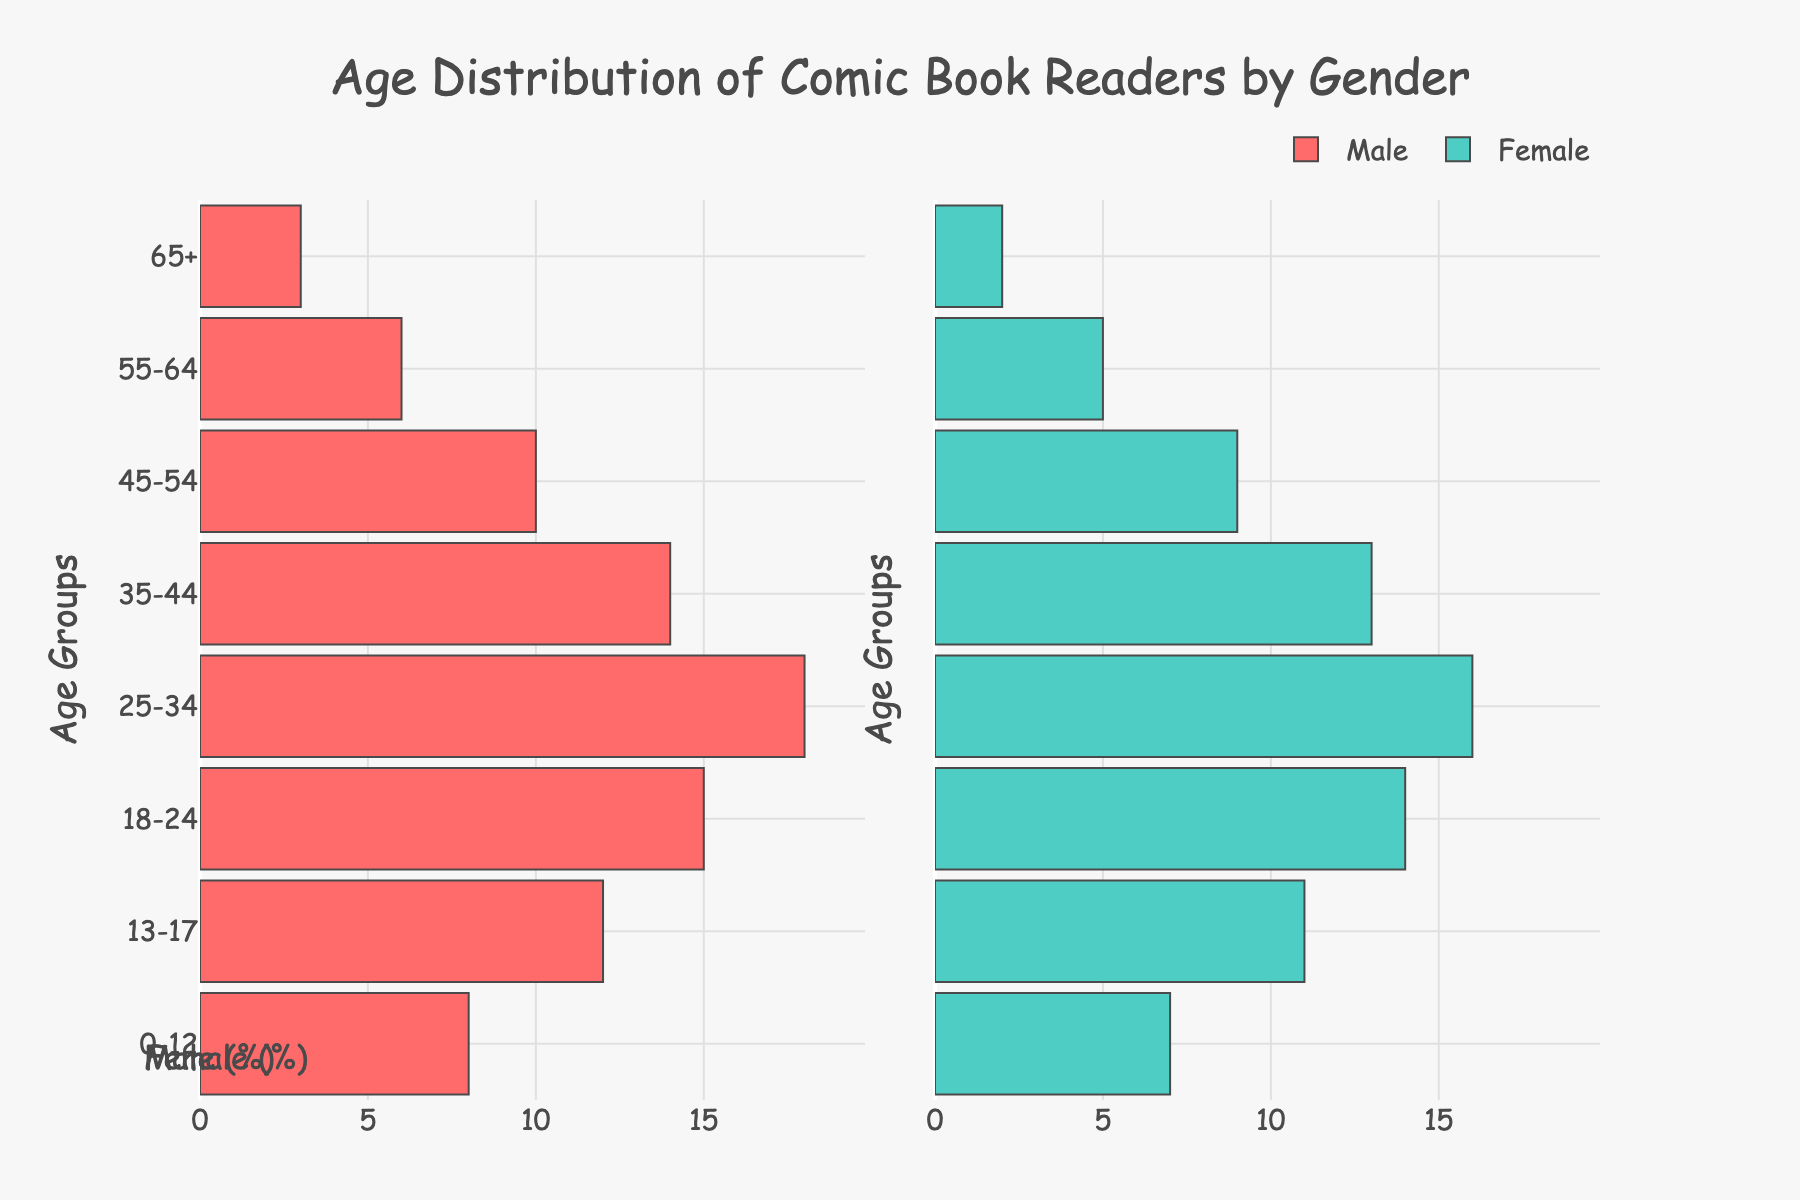What's the title of the figure? The title is located at the top of the figure and reads "Age Distribution of Comic Book Readers by Gender".
Answer: Age Distribution of Comic Book Readers by Gender What color represents male readers in the figure? The color representing male readers in the figure is red.
Answer: Red Which age group has the highest number of male comic book readers? To find the highest number, look at the length of the red bars and identify the age group with the longest bar. The "25-34" age group has the longest red bar.
Answer: 25-34 How many female comic book readers are in the "18-24" age group? Find the bar for the "18-24" age group in the female section (right side, green bar) and read its value, which is 14%.
Answer: 14 Which age group has the least number of comic book readers, regardless of gender? Compare the bars for both male and female readers across all age groups. The "65+" group has the smallest combined bar lengths for both genders.
Answer: 65+ In which age group is the gender distribution of comic book readers closest to equal? Look for age groups where the lengths of the red and green bars are most similar. The "35-44" group has bars that are relatively close in length for both genders.
Answer: 35-44 What is the total percentage of comic book readers in the "13-17" age group? Sum the percentage values for both male (12%) and female (11%) readers in the "13-17" age group: 12% + 11% = 23%.
Answer: 23% Which gender has more comic book readers in the "55-64" age group? Compare the lengths of the bars for the "55-64" age group. The red bar (male) is longer than the green bar (female), indicating more male readers.
Answer: Male How does the number of comic book readers aged 0-12 compare between males and females? Compare the lengths of the bars for the "0-12" age group on the left (male) and right (female). The red bar (8%) is longer than the green bar (7%), indicating more male readers.
Answer: More males What's the total percentage of comic book readers aged 45 and above? Combine the percentages of male and female readers from the "45-54", "55-64", and "65+" age groups: (10% + 9%) + (6% + 5%) + (3% + 2%) = 35%.
Answer: 35% 